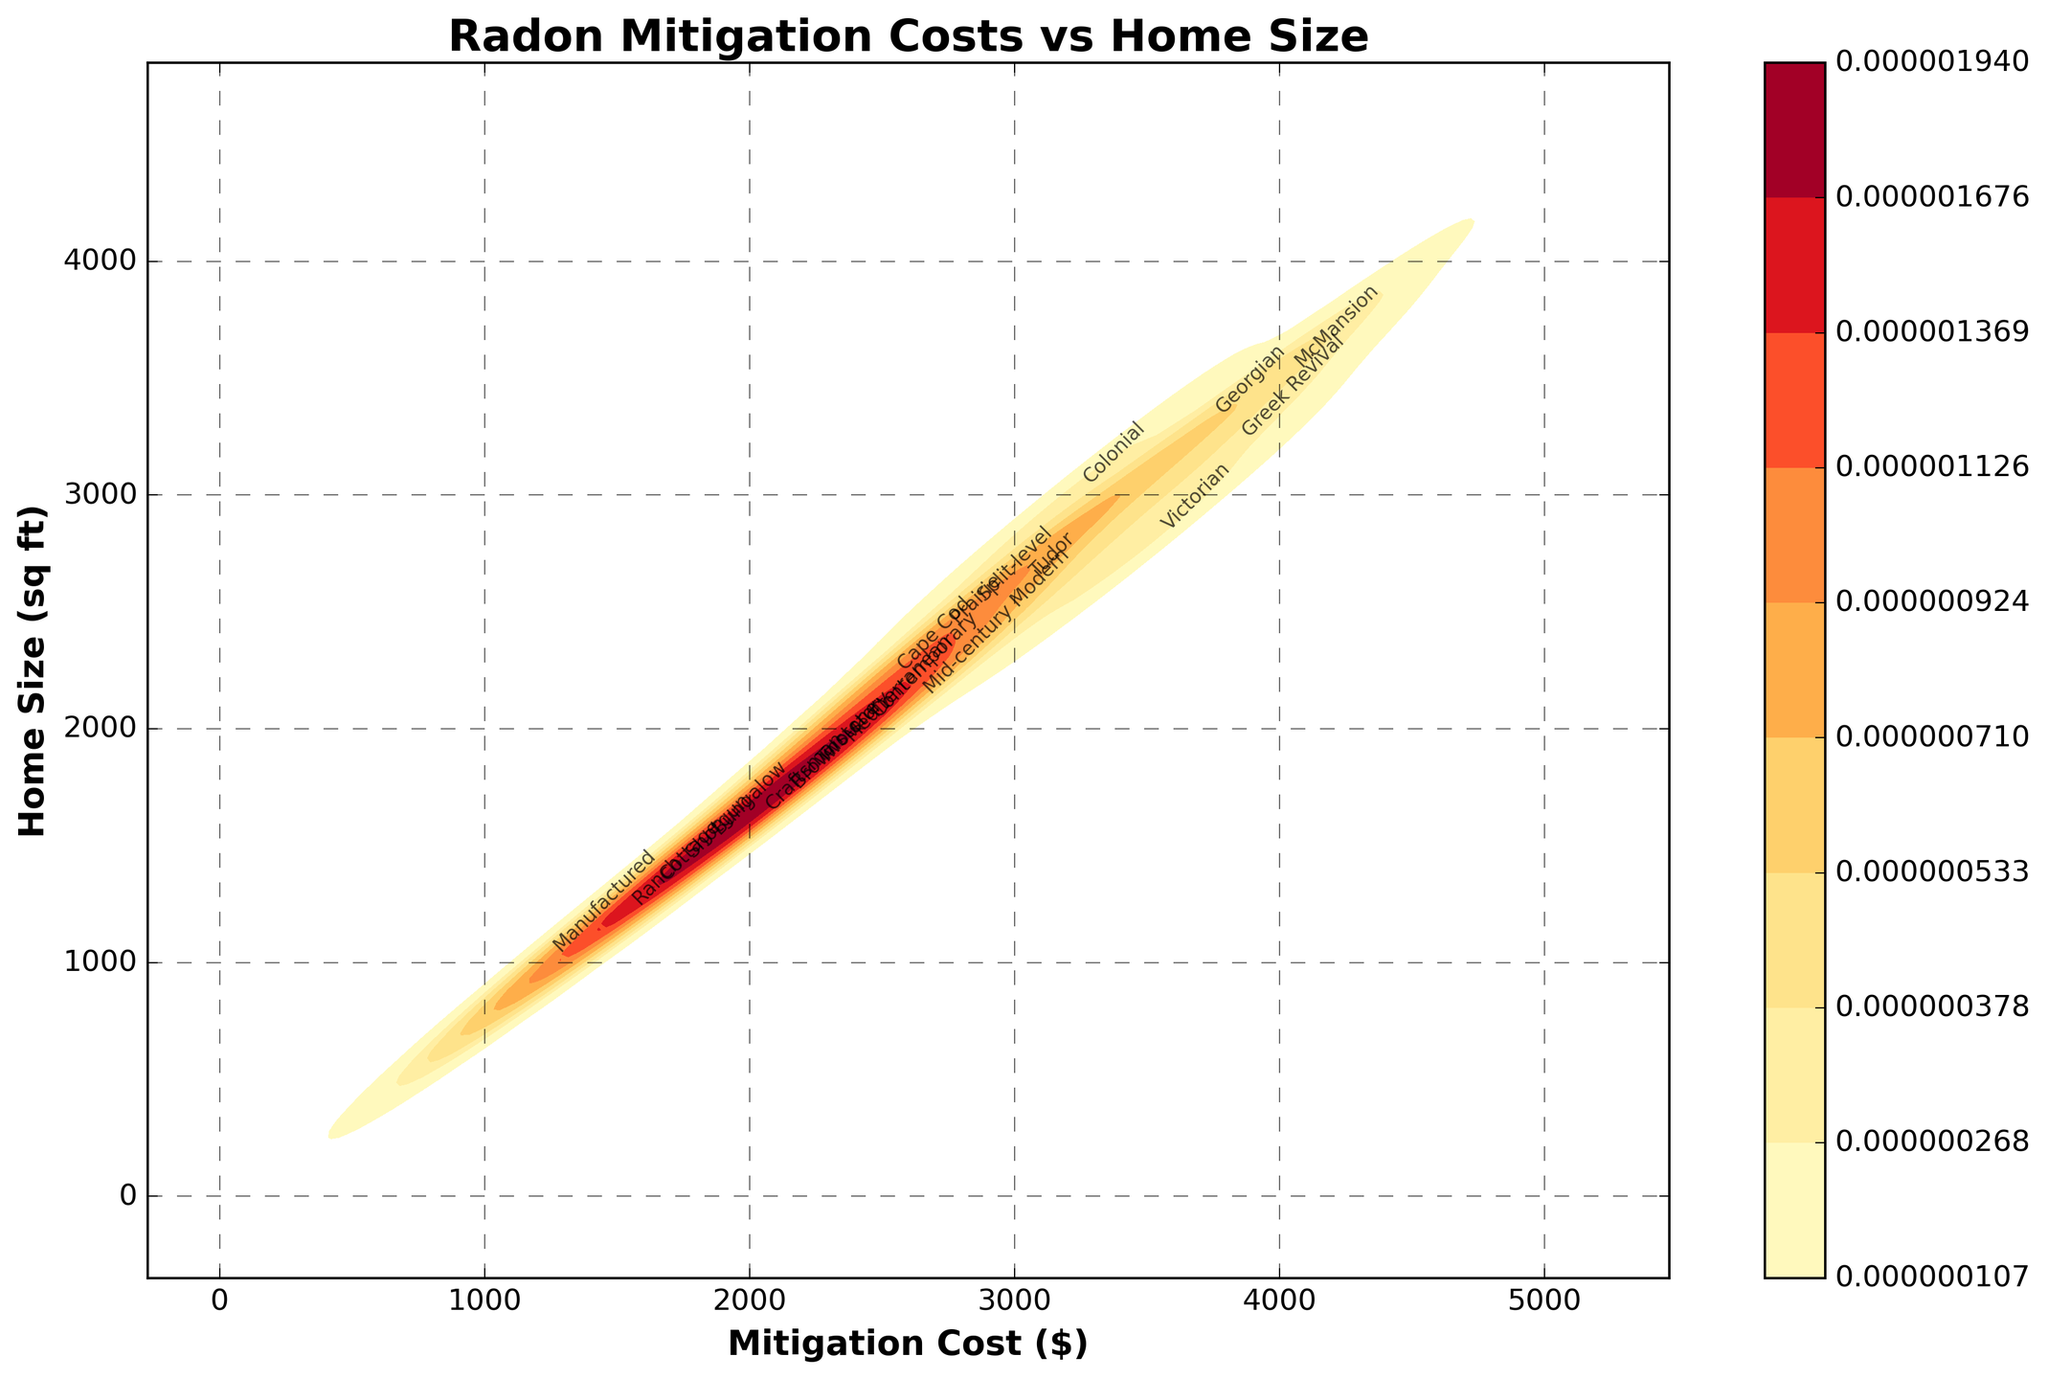What is the title of the plot? The title is prominently displayed at the top of the plot. It reads "Radon Mitigation Costs vs Home Size".
Answer: Radon Mitigation Costs vs Home Size What are the x and y axes representing? The x-axis, labeled 'Mitigation Cost ($)', represents the cost of radon mitigation in dollars. The y-axis, labeled 'Home Size (sq ft)', represents the size of the homes in square feet.
Answer: Mitigation Cost ($) and Home Size (sq ft) How does the density of mitigation costs change with increasing home size? The density plot shows shaded areas where data points are denser. As home size increases, the cost of radon mitigation generally increases, as indicated by the denser shaded areas moving from left to right with increasing y-values.
Answer: As home size increases, mitigation costs generally increase What is the highest recorded mitigation cost, and for what size home? The plot can be examined to find the point furthest to the right on the x-axis. The highest cost recorded is $4000 for a home size of 3500 sq ft.
Answer: $4000 for 3500 sq ft Which construction type has the highest radon mitigation cost? By finding the annotated construction type at the highest mitigation cost point on the plot, it shows 'McMansion' at $4000.
Answer: McMansion Which construction type is associated with the smallest home size? By locating the annotated construction type at the lowest y-axis value, it shows 'Manufactured' at 1000 sq ft.
Answer: Manufactured Compare the mitigation costs of Ranch and Bungalow type homes. Which is higher? Locate the annotations for 'Ranch' and 'Bungalow' and compare their x-axis positions. Ranch has a cost of $1500, and Bungalow has a cost of $1800, so Bungalow is higher.
Answer: Bungalow How do the costs of mitigation for homes between 2500 and 3000 sq ft compare with those between 3000 and 3500 sq ft? Identify the horizontal bands in the plot for these two ranges. Generally, for homes between 2500 and 3000 sq ft, costs range from $2800 to $3200, while for homes between 3000 and 3500 sq ft, costs range from $3200 to $4000. So, costs are higher in the larger home size range.
Answer: Costs are higher for sizes 3000-3500 sq ft What general trend can be observed regarding mitigation costs across different home sizes and construction types? Observing the overall pattern, larger and more complex homes like 'Victorian', 'Greek Revival', and 'McMansion' tend to have higher mitigation costs, indicating that both home size and construction complexity influence costs.
Answer: Larger and more complex homes have higher costs Which construction type appears around a mitigation cost of $2700? Locate the annotation nearest to the $2700 mark on the x-axis. It shows 'Prairie' at that cost.
Answer: Prairie 